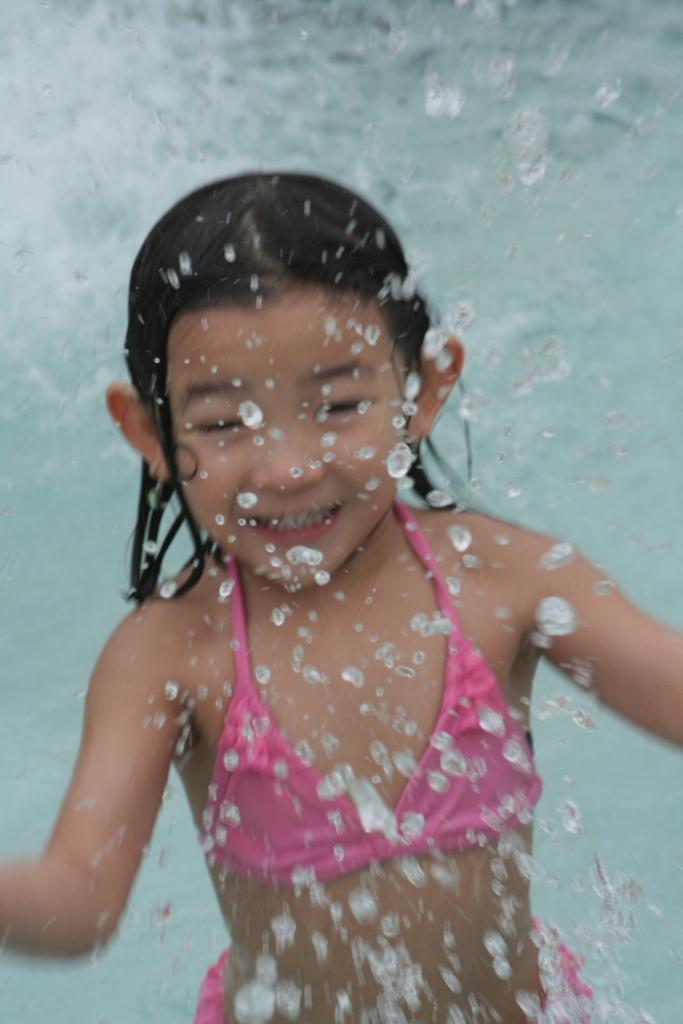Who is the main subject in the image? There is a girl in the image. What is the girl doing in the image? The girl is playing in the water. What type of kettle is the girl using to express her anger in the image? There is no kettle or any indication of anger present in the image. 